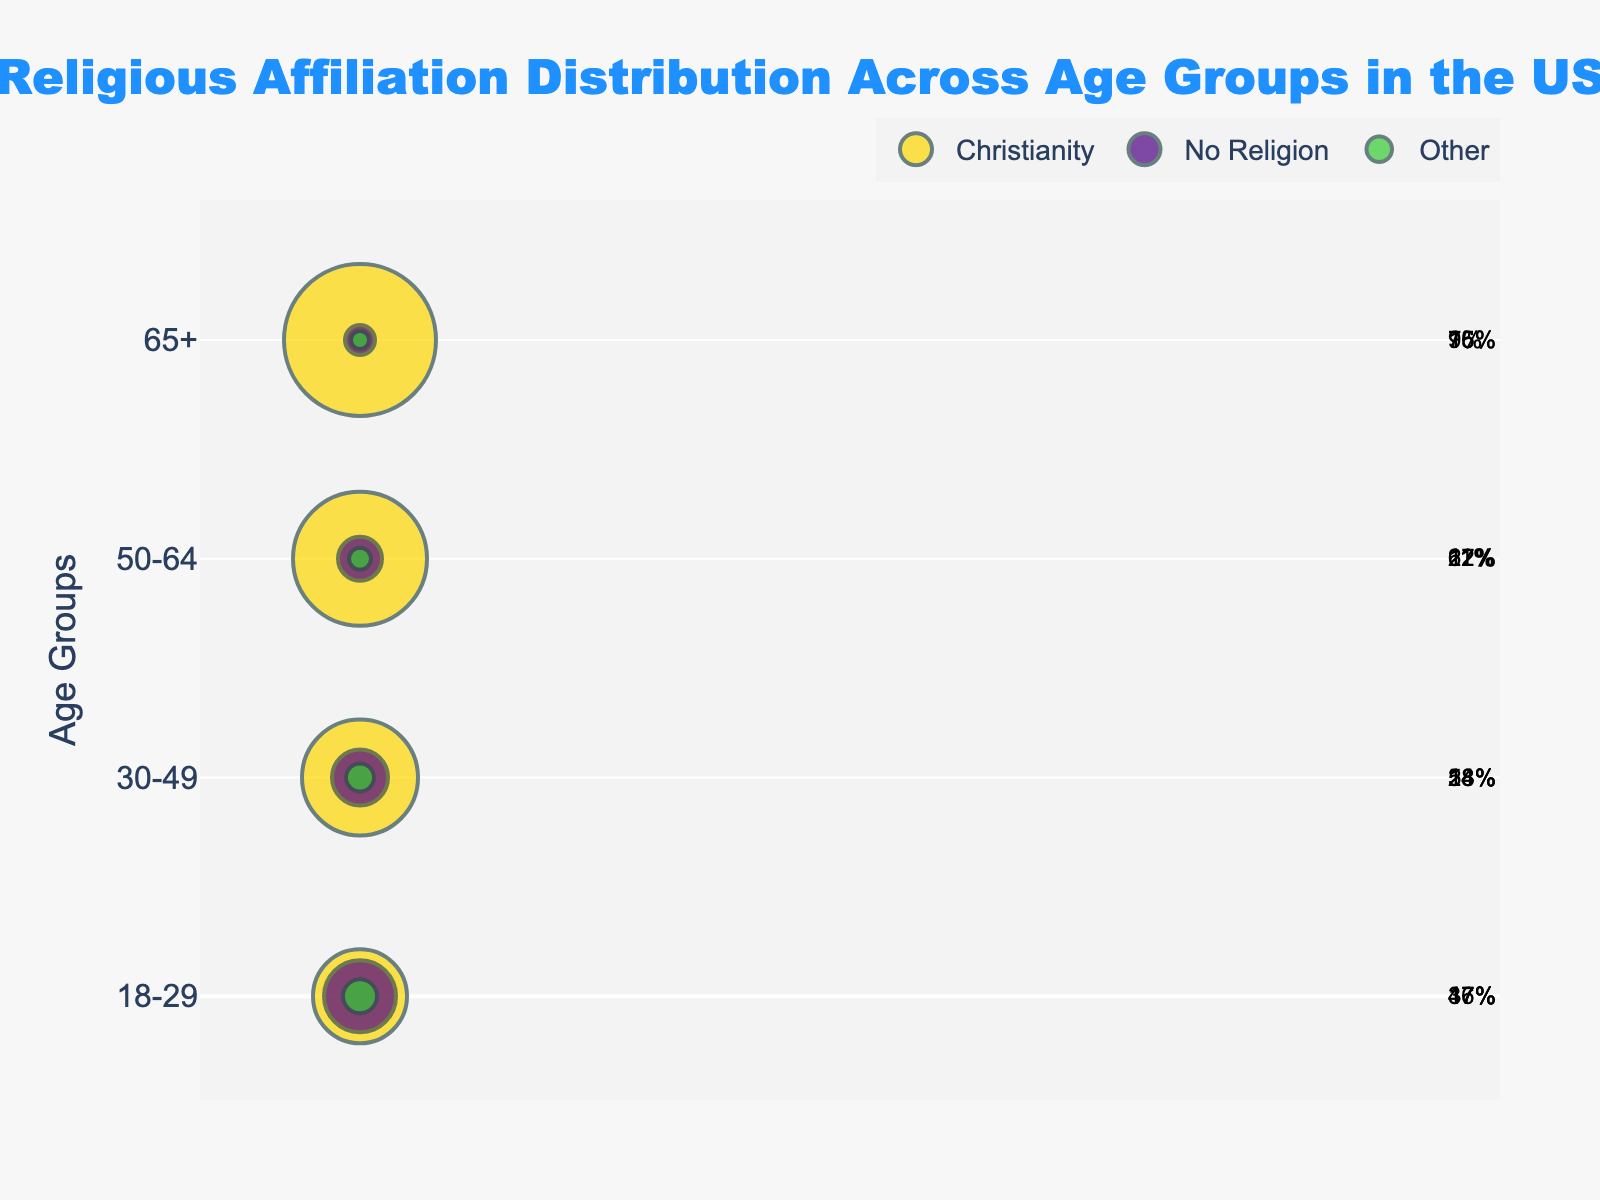What is the title of the figure? The title is generally located at the top of the plot. In this case, it reads "Religious Affiliation Distribution Across Age Groups in the US."
Answer: Religious Affiliation Distribution Across Age Groups in the US Which age group has the highest percentage of people with no religion? Each age group has markers sized according to the percentage of each religion. The largest marker for "No Religion" is in the 18-29 age group, where the percentage is 36%.
Answer: 18-29 What is the total percentage of people age 65+ having Christian or no religion? Add the percentages of Christianity and No Religion for the age group 65+. Christianity is 76% and No Religion is 15%; together, these sum to 91%.
Answer: 91% Compare the percentage of people with no religion between the age groups 18-29 and 50-64. Which one is larger and by how much? For 18-29, No Religion is at 36%, and for 50-64, it is 22%. The difference is calculated as 36% - 22%, which equals 14%.
Answer: 18-29 is larger by 14% What religion has the smallest percentage in the 30-49 age group? Examine the marker sizes and their associated percentages for the 30-49 age group. The smallest percentage appears for "Other," which is 14%.
Answer: Other Which age group has the highest diversity of religious affiliations? The diversity can be judged by how evenly different religious groups are distributed. The 18-29 age group has a noticeable distribution close to 47% Christianity, 36% No Religion, and 17% Other.
Answer: 18-29 What is the visual format for the age groups on the y-axis? Look at the y-axis, which should show the age groups in text format arranged vertically. The age groups are presented as "18-29," "30-49," "50-64," and "65+."
Answer: "18-29," "30-49," "50-64," "65+" How does the percentage of Christianity change from the 18-29 age group to the 65+ age group? Observe and compare the Christianity percentages for the given age groups. From 18-29 (47%) to 65+ (76%), there's an increment. The change is 76% - 47%, which is a 29% increase.
Answer: Increases by 29% Which age group has the highest percentage of people adhering to Christianity? How much is it? Check each marker size and percentage for Christianity. The highest percentage is found in the age group 65+, which stands at 76%.
Answer: 65+, 76% 